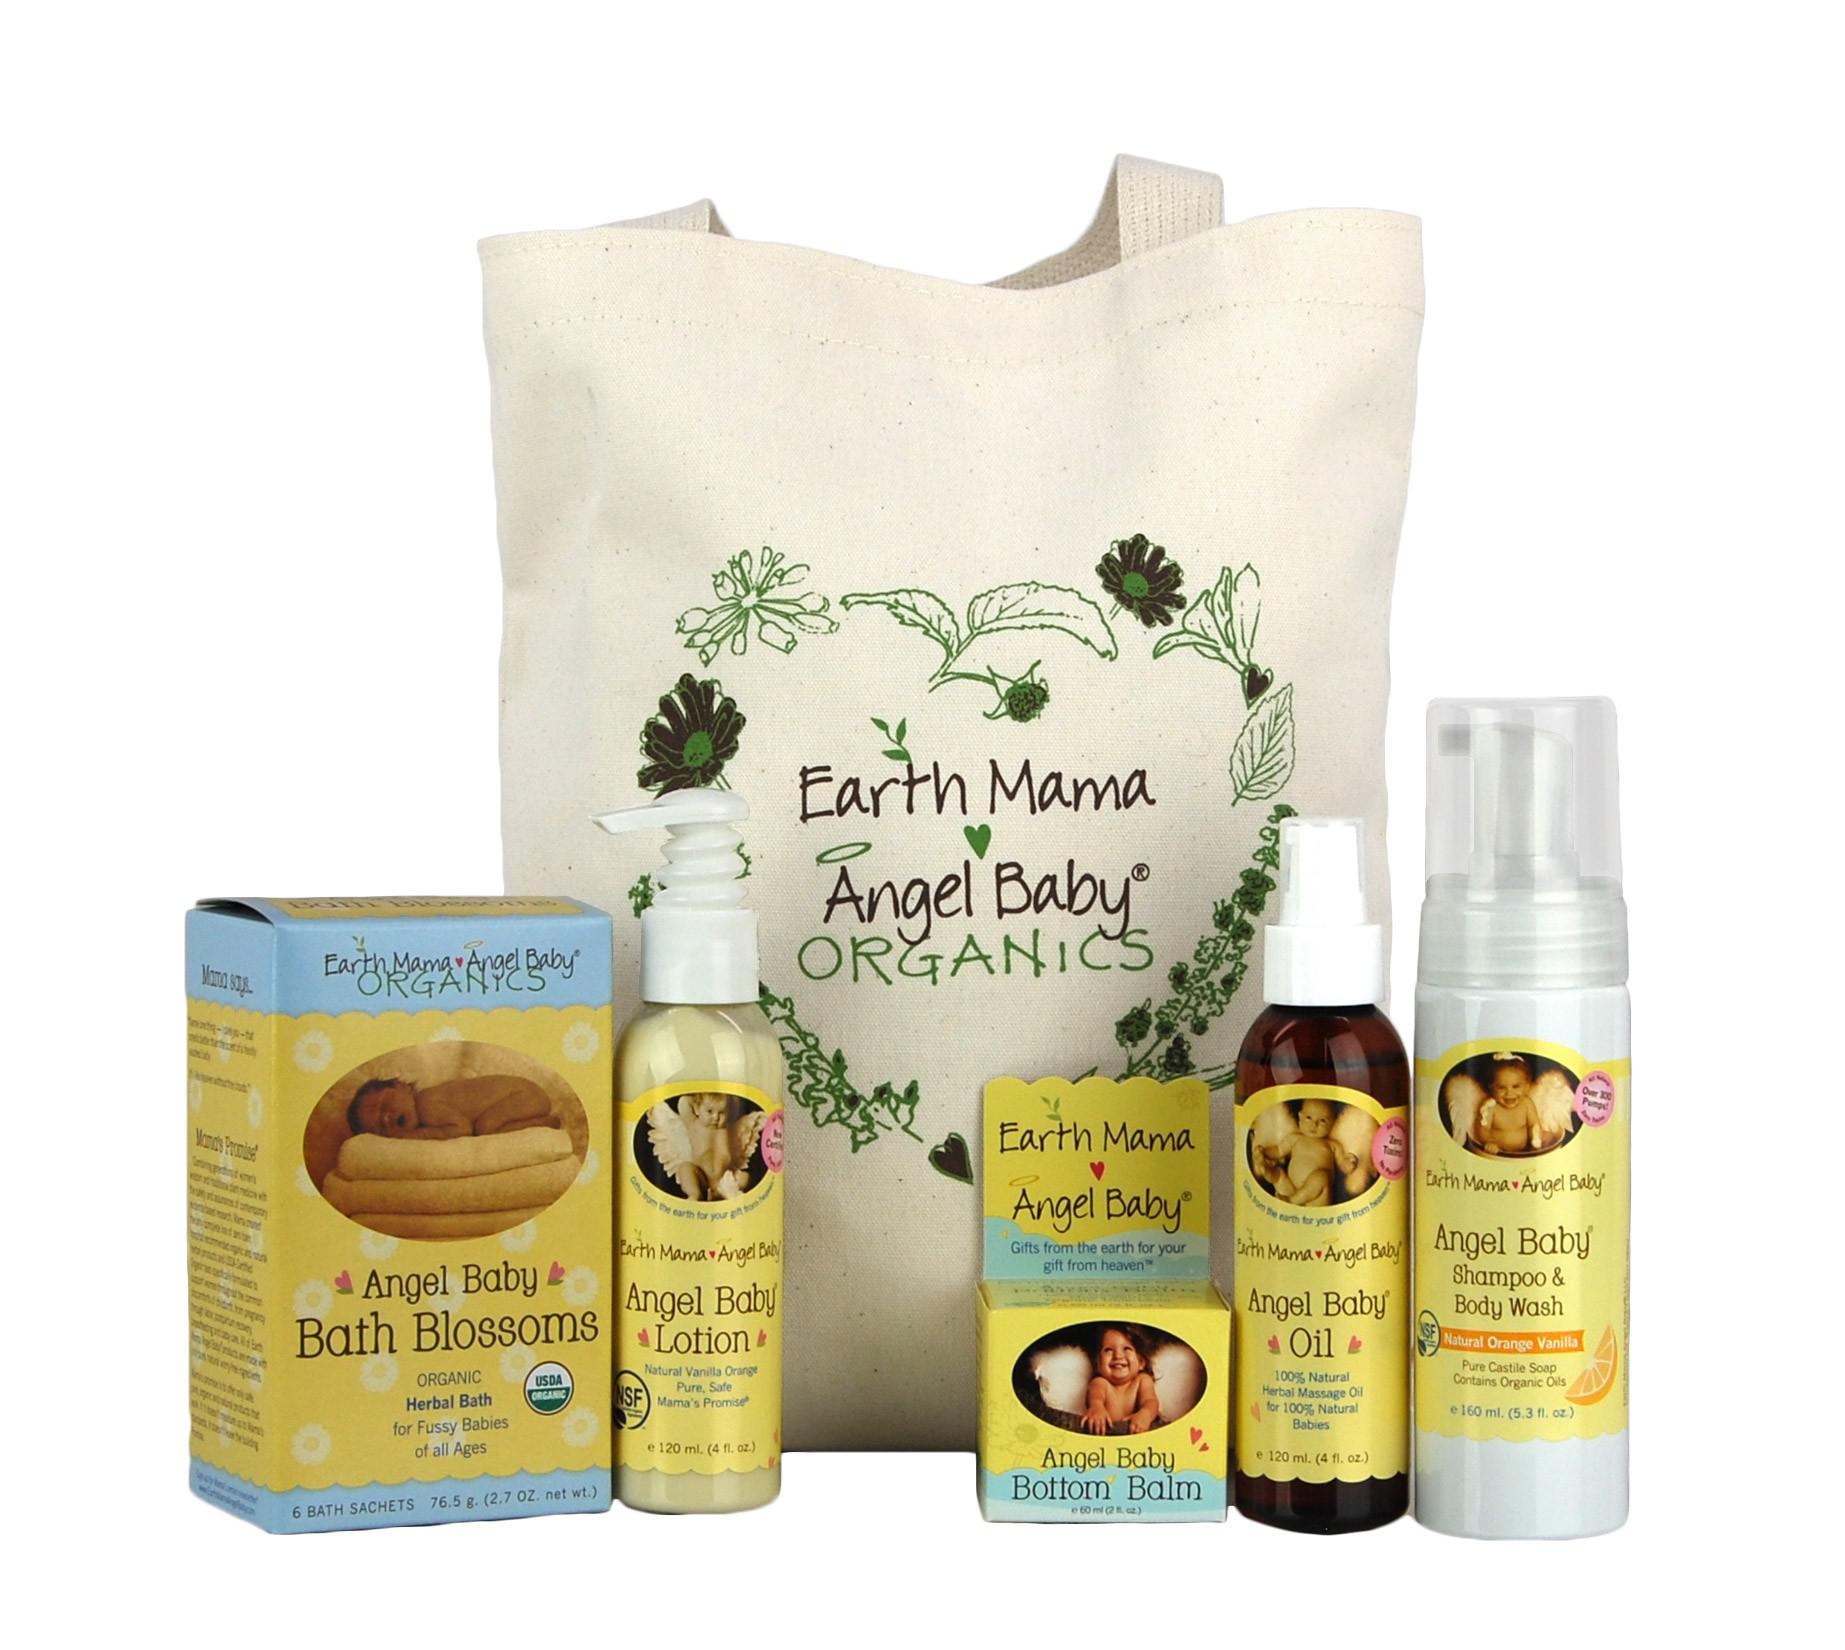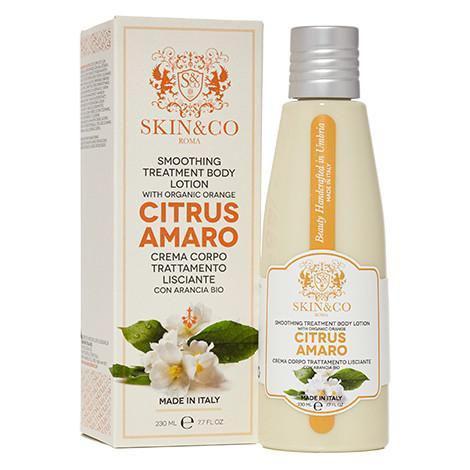The first image is the image on the left, the second image is the image on the right. Examine the images to the left and right. Is the description "A product is standing next to its box." accurate? Answer yes or no. Yes. The first image is the image on the left, the second image is the image on the right. For the images displayed, is the sentence "Each image contains exactly one product with a black pump top, and one image features a pump bottle with a yellow bow, but the pump nozzles on the left and right face different directions." factually correct? Answer yes or no. No. 